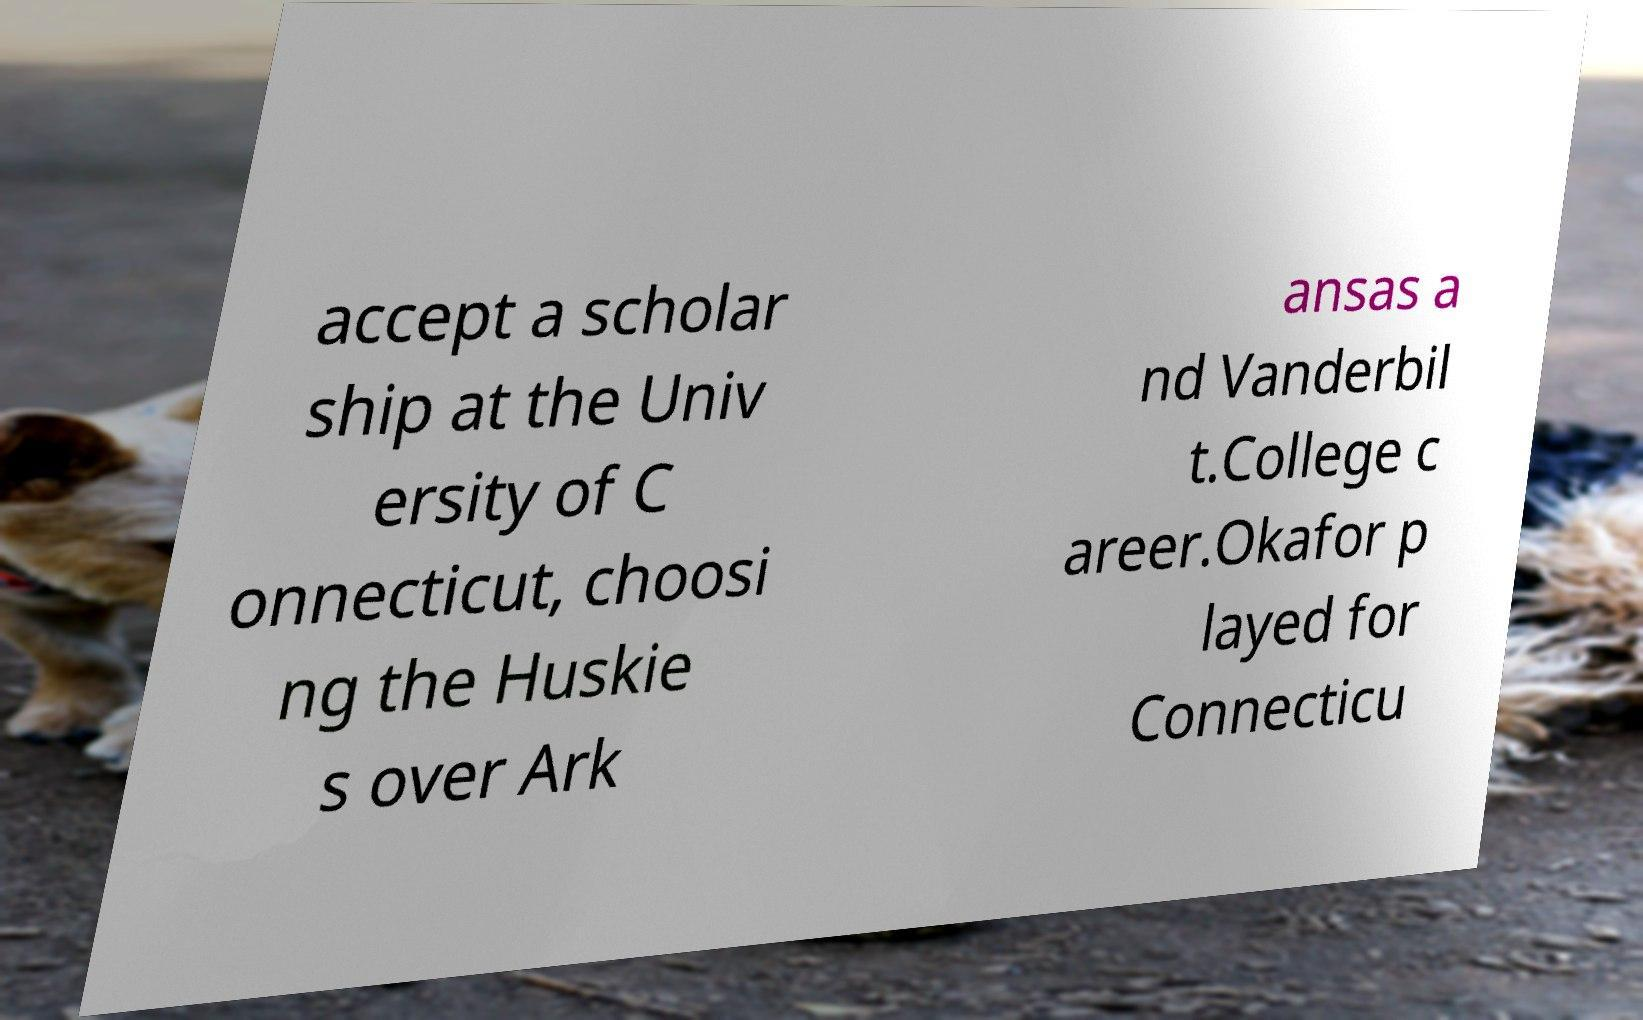Can you accurately transcribe the text from the provided image for me? accept a scholar ship at the Univ ersity of C onnecticut, choosi ng the Huskie s over Ark ansas a nd Vanderbil t.College c areer.Okafor p layed for Connecticu 